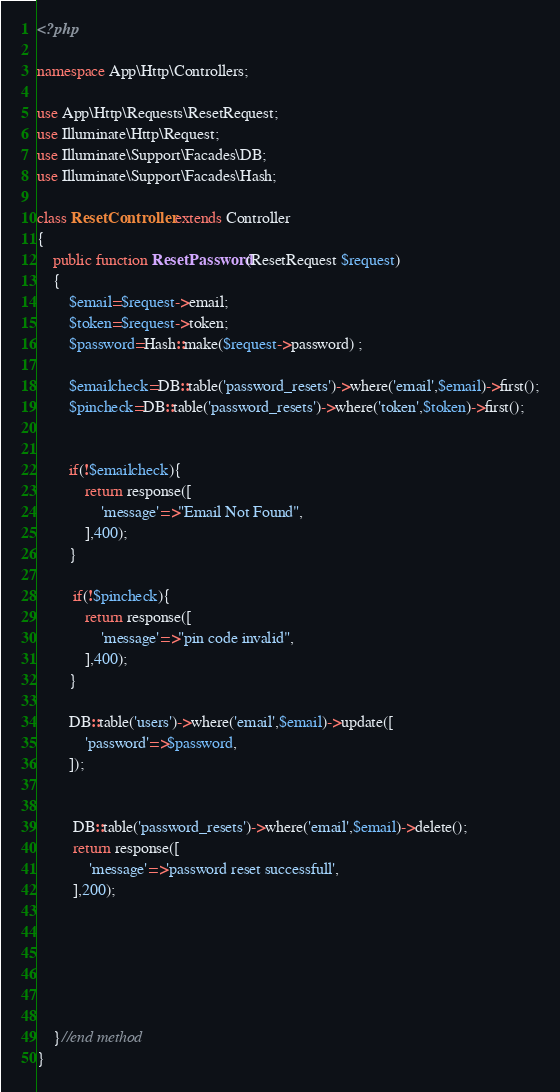Convert code to text. <code><loc_0><loc_0><loc_500><loc_500><_PHP_><?php

namespace App\Http\Controllers;

use App\Http\Requests\ResetRequest;
use Illuminate\Http\Request;
use Illuminate\Support\Facades\DB;
use Illuminate\Support\Facades\Hash;

class ResetController extends Controller
{
    public function ResetPassword(ResetRequest $request)
    {
        $email=$request->email;
        $token=$request->token;
        $password=Hash::make($request->password) ;

        $emailcheck=DB::table('password_resets')->where('email',$email)->first();
        $pincheck=DB::table('password_resets')->where('token',$token)->first();


        if(!$emailcheck){
            return response([
                'message'=>"Email Not Found",
            ],400);
        }

         if(!$pincheck){
            return response([
                'message'=>"pin code invalid",
            ],400);
        }

        DB::table('users')->where('email',$email)->update([
            'password'=>$password,
        ]);


         DB::table('password_resets')->where('email',$email)->delete();
         return response([
             'message'=>'password reset successfull',
         ],200);






    }//end method
}
</code> 